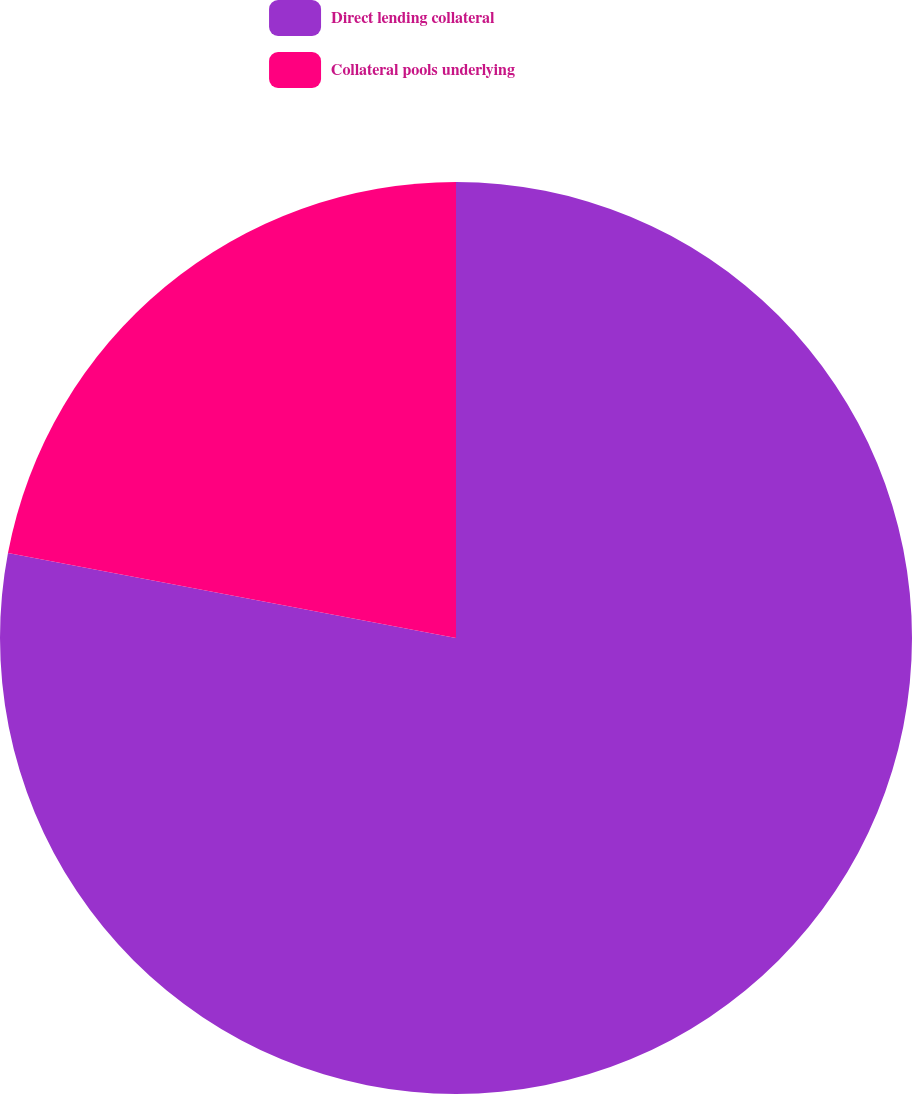Convert chart to OTSL. <chart><loc_0><loc_0><loc_500><loc_500><pie_chart><fcel>Direct lending collateral<fcel>Collateral pools underlying<nl><fcel>77.98%<fcel>22.02%<nl></chart> 